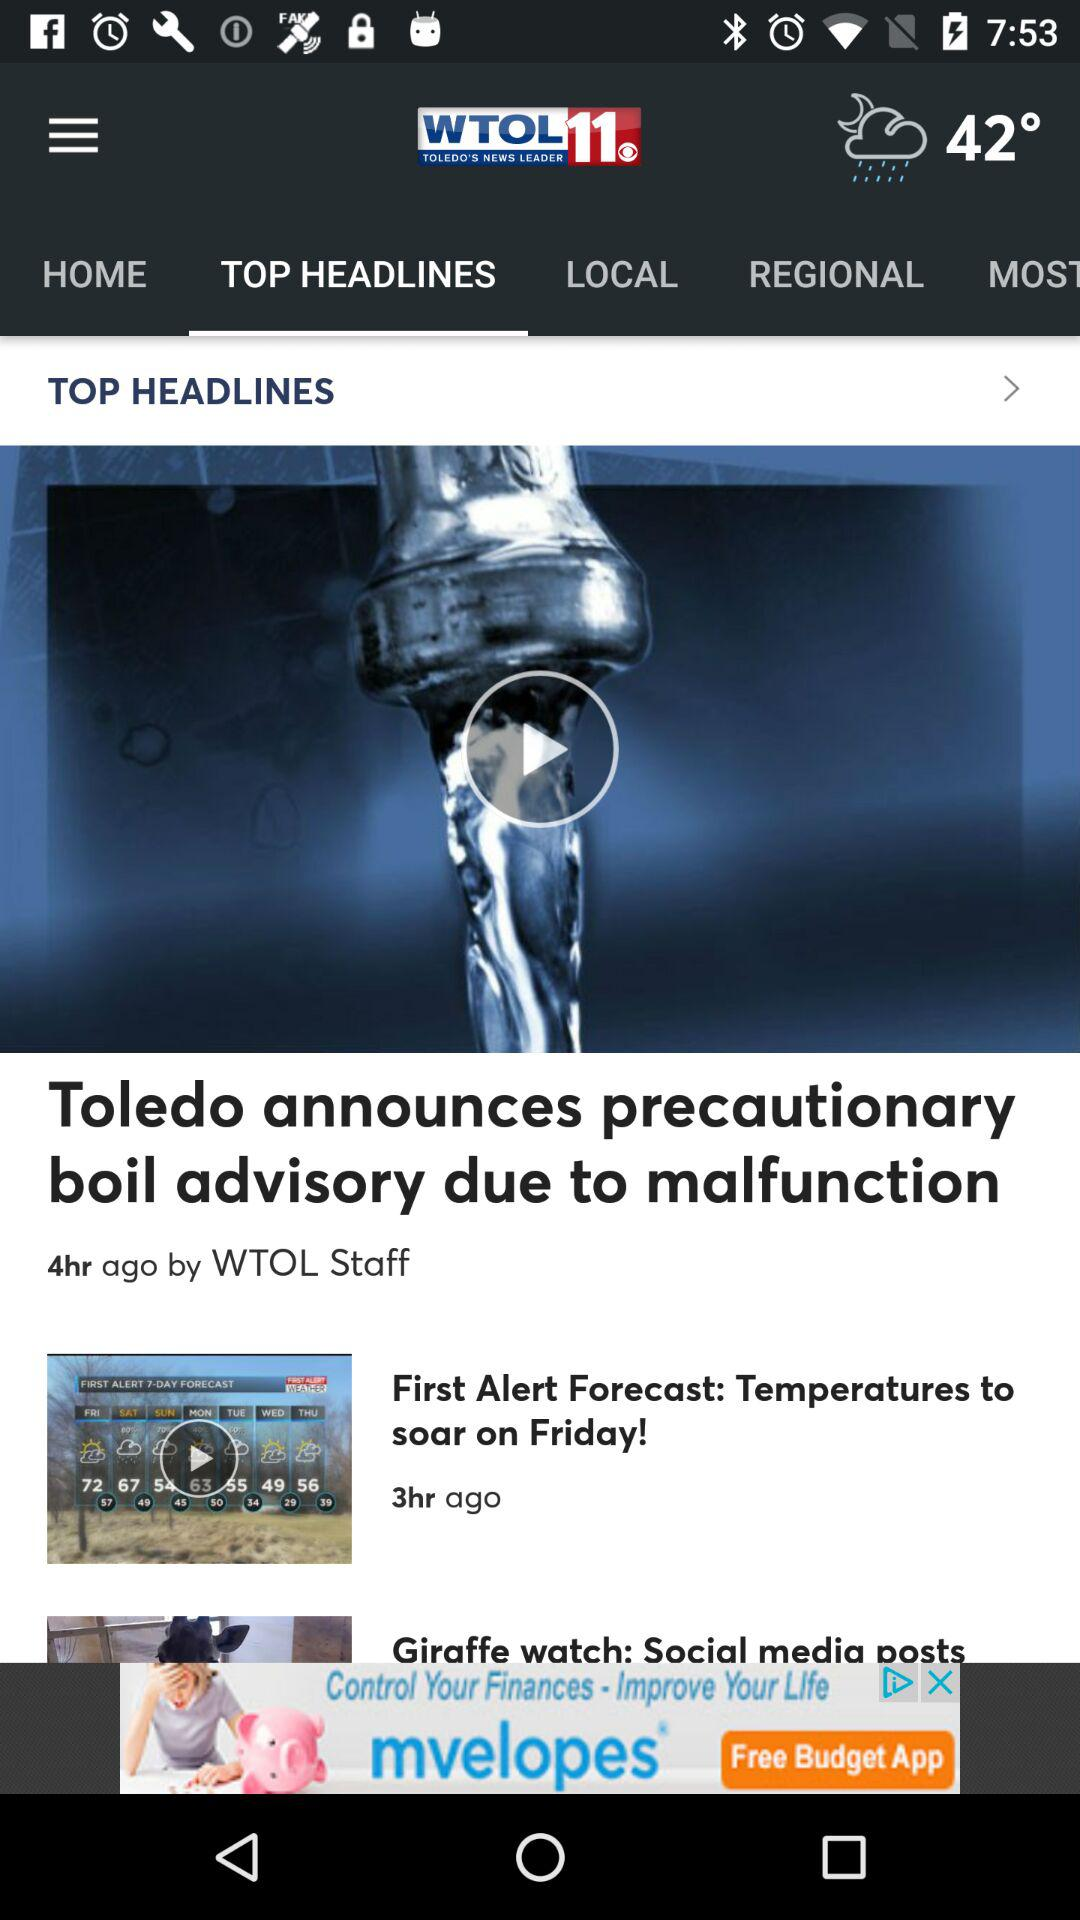When was the article "Toledo announces precautionary boil advisory due to malfunction" published? The article "Toledo announces precautionary boil advisory due to malfunction" was published 4 hours ago. 